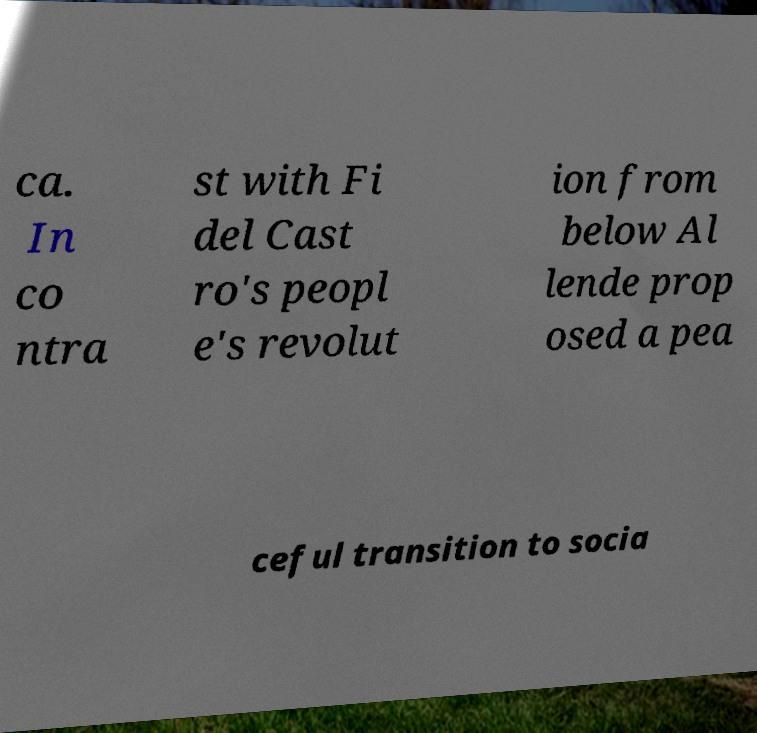I need the written content from this picture converted into text. Can you do that? ca. In co ntra st with Fi del Cast ro's peopl e's revolut ion from below Al lende prop osed a pea ceful transition to socia 